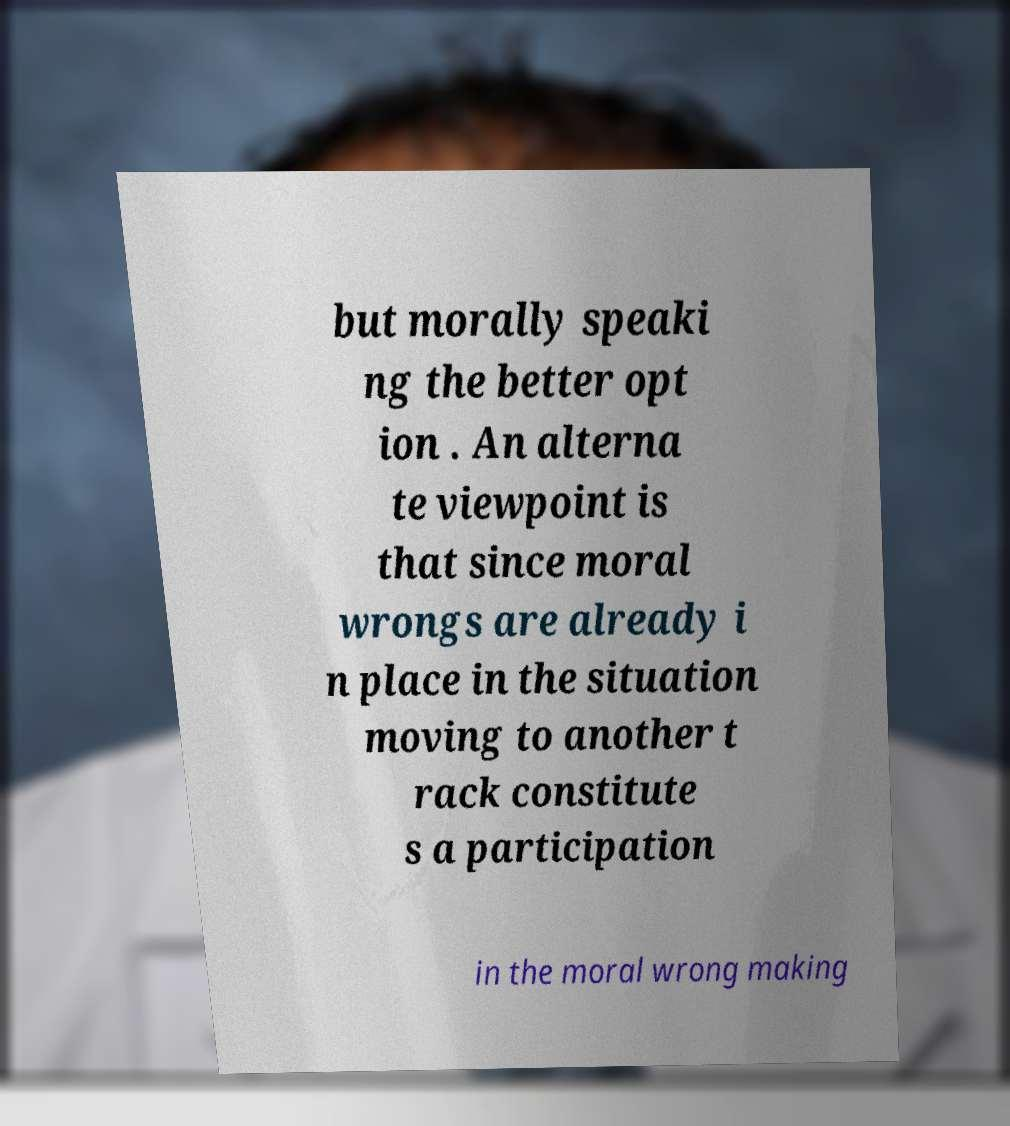I need the written content from this picture converted into text. Can you do that? but morally speaki ng the better opt ion . An alterna te viewpoint is that since moral wrongs are already i n place in the situation moving to another t rack constitute s a participation in the moral wrong making 